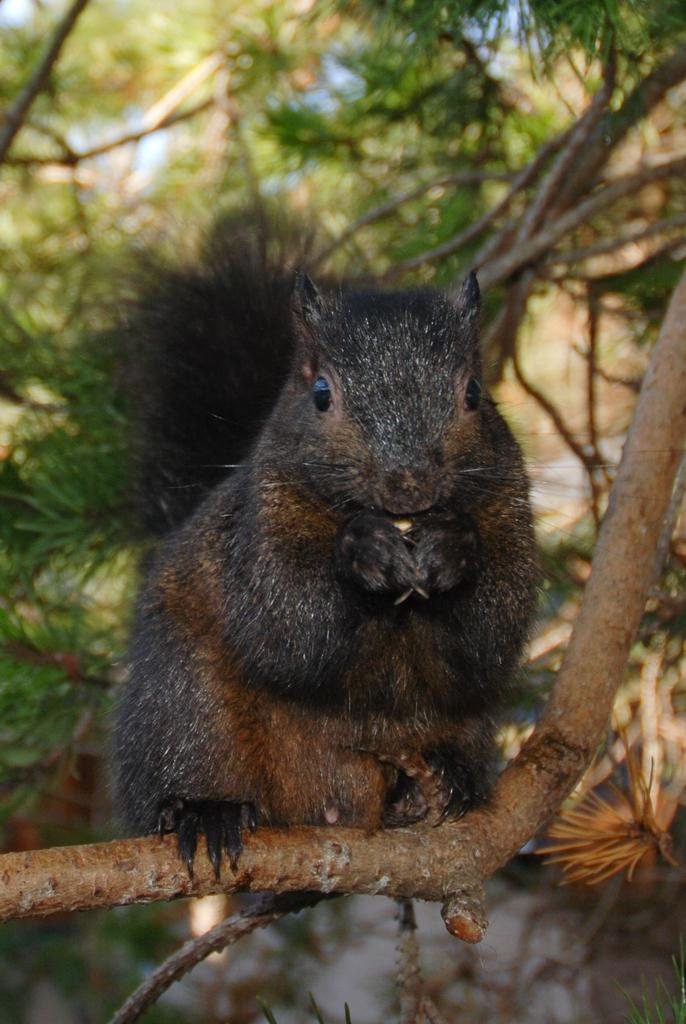What animal can be seen in the image? There is a squirrel in the image. Where is the squirrel located? The squirrel is on a branch. What can be seen in the background of the image? There are trees in the background of the image. What type of honey is the squirrel collecting from the boats in the cemetery? There are no boats or cemetery present in the image, and the squirrel is not collecting honey. 